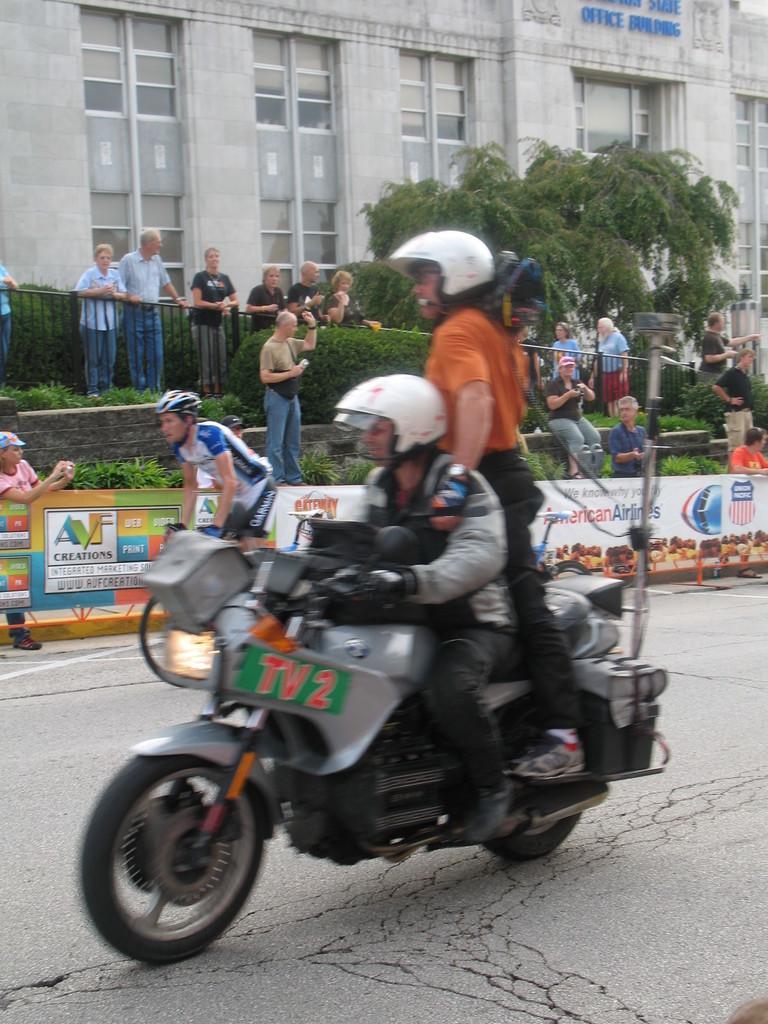Could you give a brief overview of what you see in this image? In the center of the image there are people riding a bike wearing a helmet. In the background of the image there are people. There is a building with windows. There is tree. There is a fencing. At the bottom of the image there is a road. 